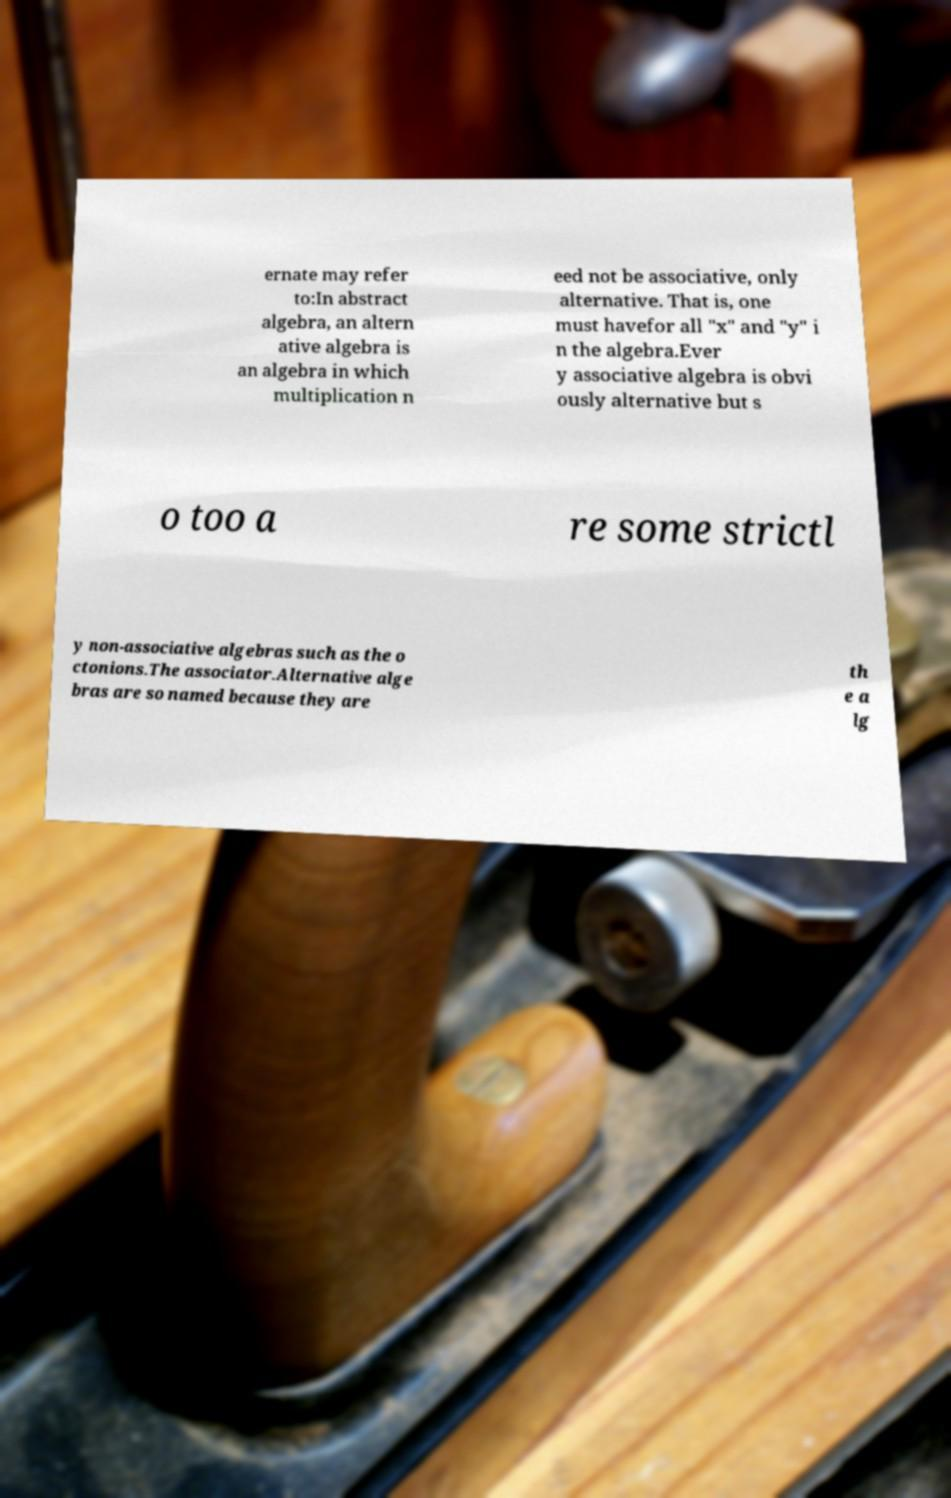Could you extract and type out the text from this image? ernate may refer to:In abstract algebra, an altern ative algebra is an algebra in which multiplication n eed not be associative, only alternative. That is, one must havefor all "x" and "y" i n the algebra.Ever y associative algebra is obvi ously alternative but s o too a re some strictl y non-associative algebras such as the o ctonions.The associator.Alternative alge bras are so named because they are th e a lg 